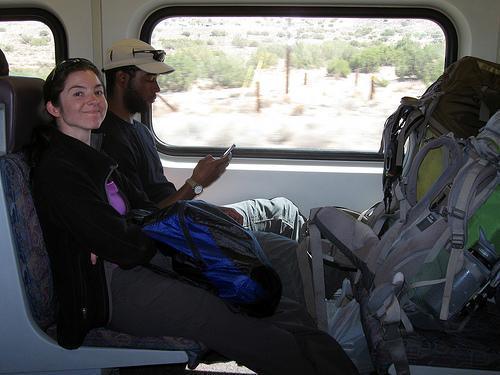How many backpacks are there?
Give a very brief answer. 2. How many people are there?
Give a very brief answer. 2. 